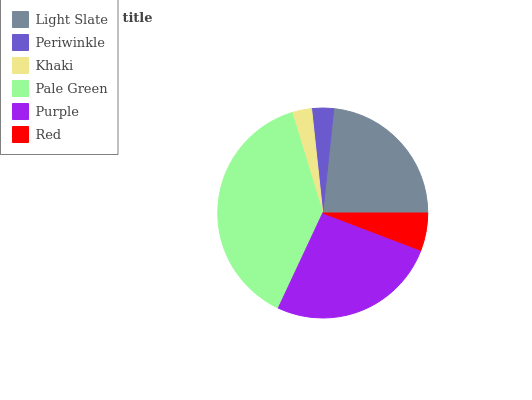Is Khaki the minimum?
Answer yes or no. Yes. Is Pale Green the maximum?
Answer yes or no. Yes. Is Periwinkle the minimum?
Answer yes or no. No. Is Periwinkle the maximum?
Answer yes or no. No. Is Light Slate greater than Periwinkle?
Answer yes or no. Yes. Is Periwinkle less than Light Slate?
Answer yes or no. Yes. Is Periwinkle greater than Light Slate?
Answer yes or no. No. Is Light Slate less than Periwinkle?
Answer yes or no. No. Is Light Slate the high median?
Answer yes or no. Yes. Is Red the low median?
Answer yes or no. Yes. Is Periwinkle the high median?
Answer yes or no. No. Is Light Slate the low median?
Answer yes or no. No. 